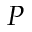Convert formula to latex. <formula><loc_0><loc_0><loc_500><loc_500>P</formula> 